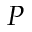Convert formula to latex. <formula><loc_0><loc_0><loc_500><loc_500>P</formula> 